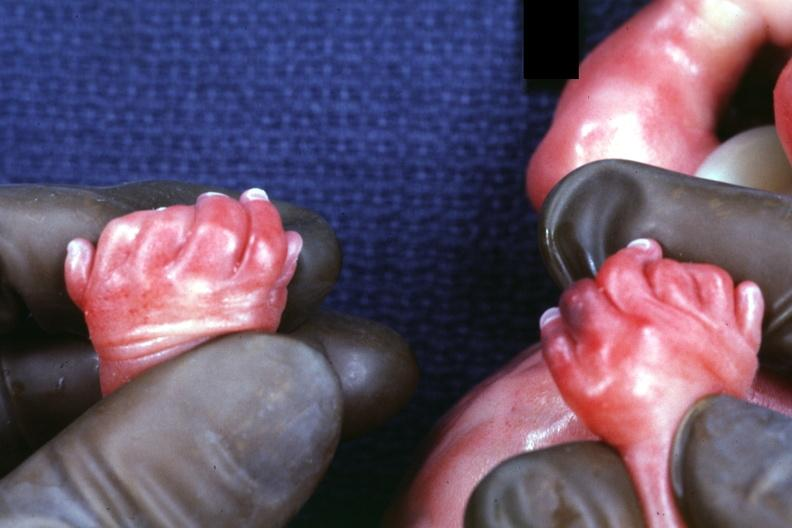what does child have?
Answer the question using a single word or phrase. Polycystic disease 